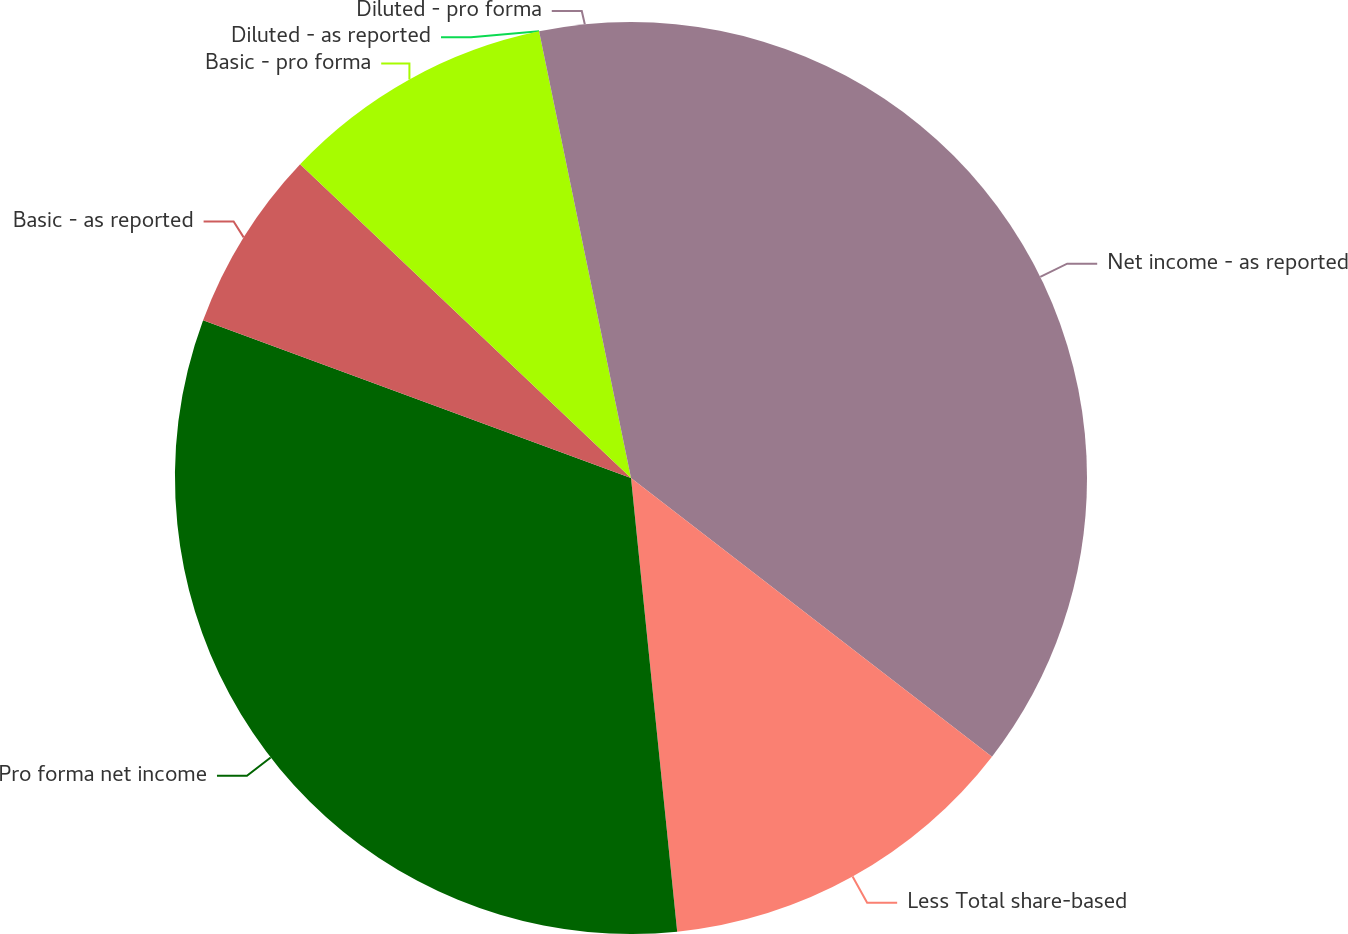Convert chart. <chart><loc_0><loc_0><loc_500><loc_500><pie_chart><fcel>Net income - as reported<fcel>Less Total share-based<fcel>Pro forma net income<fcel>Basic - as reported<fcel>Basic - pro forma<fcel>Diluted - as reported<fcel>Diluted - pro forma<nl><fcel>35.46%<fcel>12.92%<fcel>32.23%<fcel>6.46%<fcel>9.69%<fcel>0.0%<fcel>3.23%<nl></chart> 